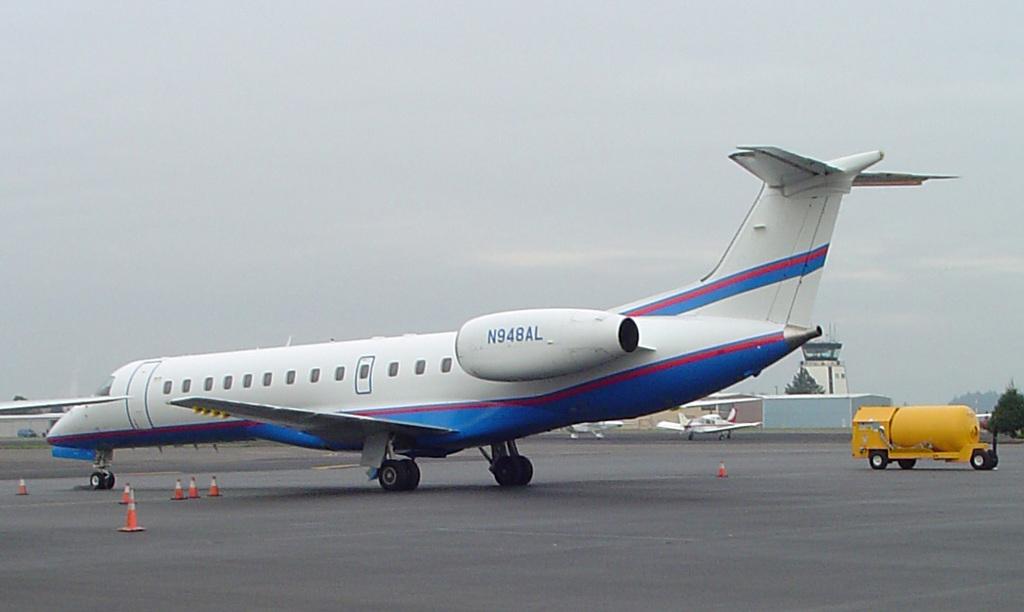What is the model number of the plane?
Make the answer very short. N948al. 